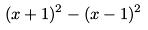Convert formula to latex. <formula><loc_0><loc_0><loc_500><loc_500>( x + 1 ) ^ { 2 } - ( x - 1 ) ^ { 2 }</formula> 